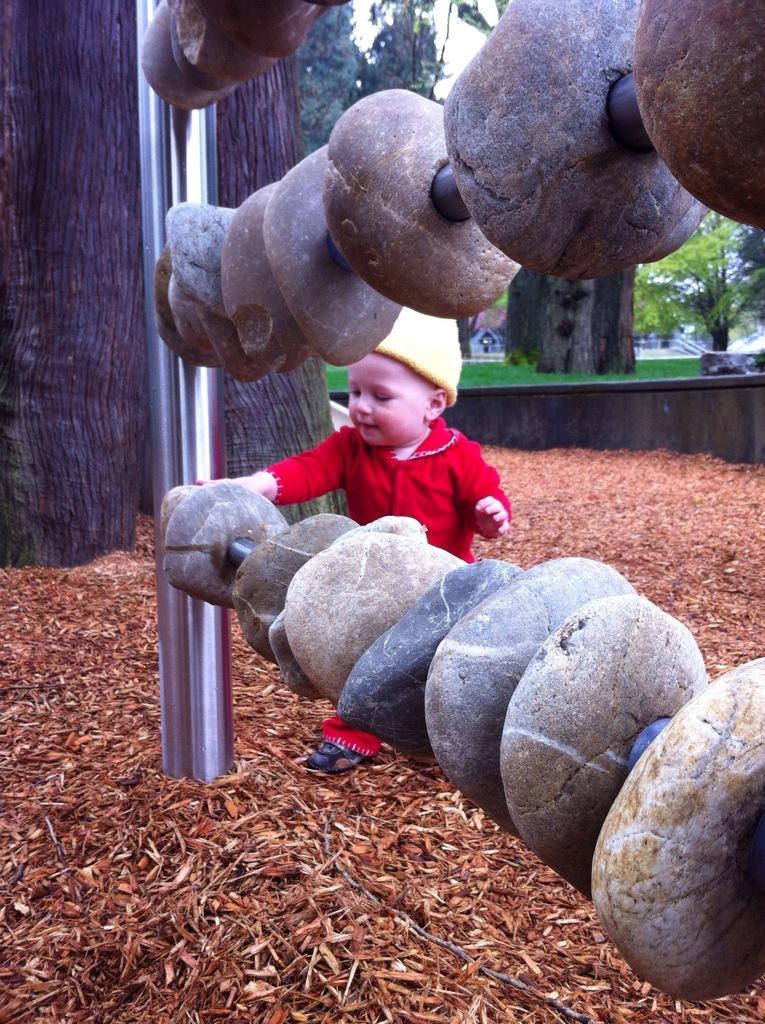Describe this image in one or two sentences. Here in this picture we can see some stones inserted in rods, which are present on the pole over there and in the middle we can see a baby standing and touching the stones and behind him we can see trees present all over there. 